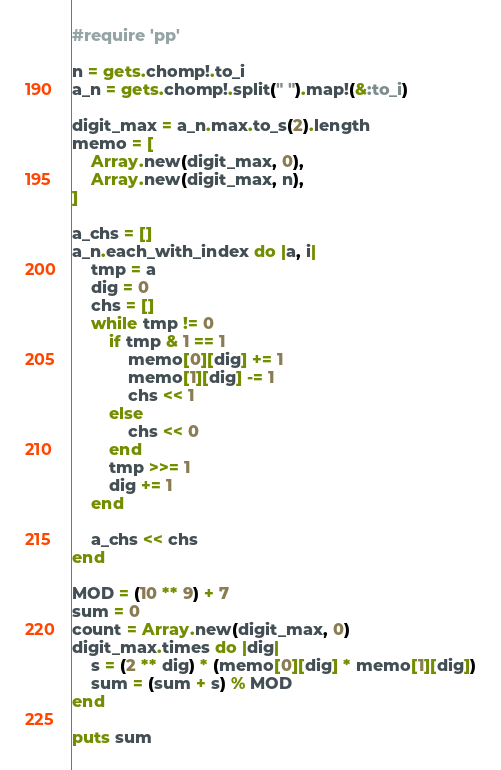Convert code to text. <code><loc_0><loc_0><loc_500><loc_500><_Ruby_>#require 'pp'

n = gets.chomp!.to_i
a_n = gets.chomp!.split(" ").map!(&:to_i)
    
digit_max = a_n.max.to_s(2).length
memo = [
    Array.new(digit_max, 0),
    Array.new(digit_max, n),
]

a_chs = []
a_n.each_with_index do |a, i|
    tmp = a
    dig = 0
    chs = []
    while tmp != 0
        if tmp & 1 == 1
            memo[0][dig] += 1
            memo[1][dig] -= 1
            chs << 1
        else
            chs << 0
        end
        tmp >>= 1
        dig += 1
    end

    a_chs << chs
end

MOD = (10 ** 9) + 7
sum = 0
count = Array.new(digit_max, 0)
digit_max.times do |dig|
    s = (2 ** dig) * (memo[0][dig] * memo[1][dig])
    sum = (sum + s) % MOD
end
    
puts sum
</code> 